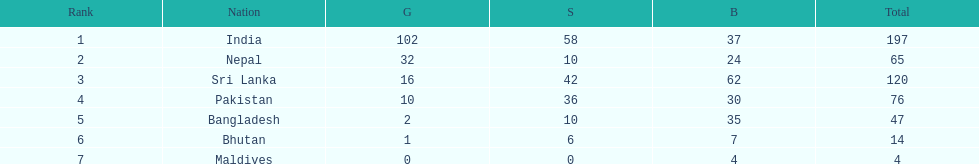What are the total number of bronze medals sri lanka have earned? 62. 